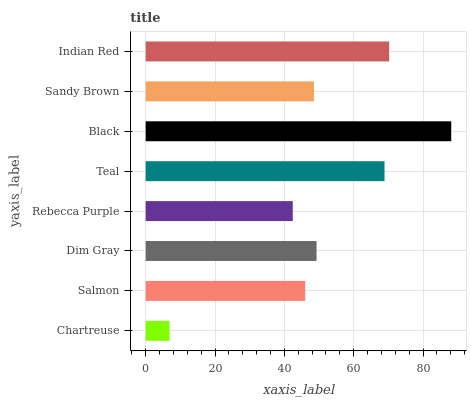Is Chartreuse the minimum?
Answer yes or no. Yes. Is Black the maximum?
Answer yes or no. Yes. Is Salmon the minimum?
Answer yes or no. No. Is Salmon the maximum?
Answer yes or no. No. Is Salmon greater than Chartreuse?
Answer yes or no. Yes. Is Chartreuse less than Salmon?
Answer yes or no. Yes. Is Chartreuse greater than Salmon?
Answer yes or no. No. Is Salmon less than Chartreuse?
Answer yes or no. No. Is Dim Gray the high median?
Answer yes or no. Yes. Is Sandy Brown the low median?
Answer yes or no. Yes. Is Rebecca Purple the high median?
Answer yes or no. No. Is Rebecca Purple the low median?
Answer yes or no. No. 